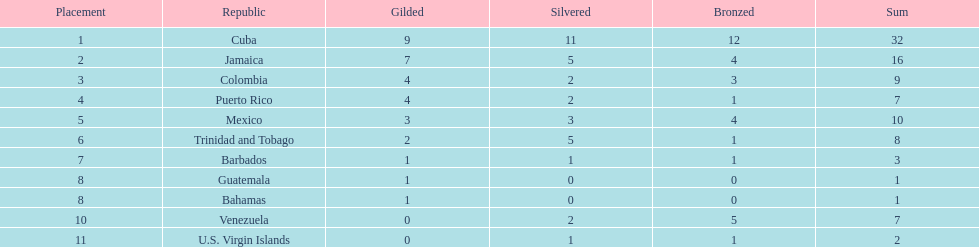Who had more silvers? colmbia or the bahamas Colombia. 